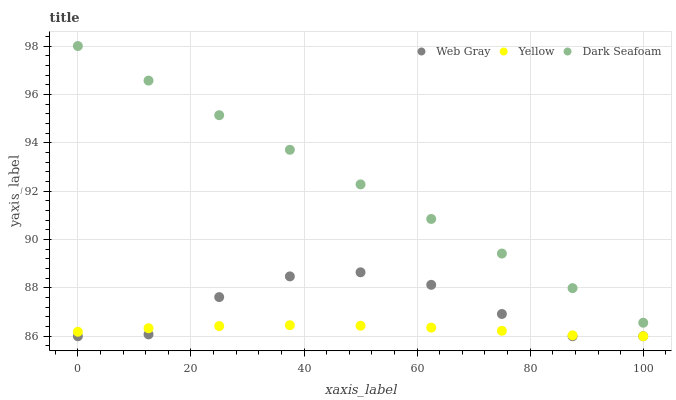Does Yellow have the minimum area under the curve?
Answer yes or no. Yes. Does Dark Seafoam have the maximum area under the curve?
Answer yes or no. Yes. Does Web Gray have the minimum area under the curve?
Answer yes or no. No. Does Web Gray have the maximum area under the curve?
Answer yes or no. No. Is Dark Seafoam the smoothest?
Answer yes or no. Yes. Is Web Gray the roughest?
Answer yes or no. Yes. Is Yellow the smoothest?
Answer yes or no. No. Is Yellow the roughest?
Answer yes or no. No. Does Web Gray have the lowest value?
Answer yes or no. Yes. Does Dark Seafoam have the highest value?
Answer yes or no. Yes. Does Web Gray have the highest value?
Answer yes or no. No. Is Web Gray less than Dark Seafoam?
Answer yes or no. Yes. Is Dark Seafoam greater than Web Gray?
Answer yes or no. Yes. Does Web Gray intersect Yellow?
Answer yes or no. Yes. Is Web Gray less than Yellow?
Answer yes or no. No. Is Web Gray greater than Yellow?
Answer yes or no. No. Does Web Gray intersect Dark Seafoam?
Answer yes or no. No. 